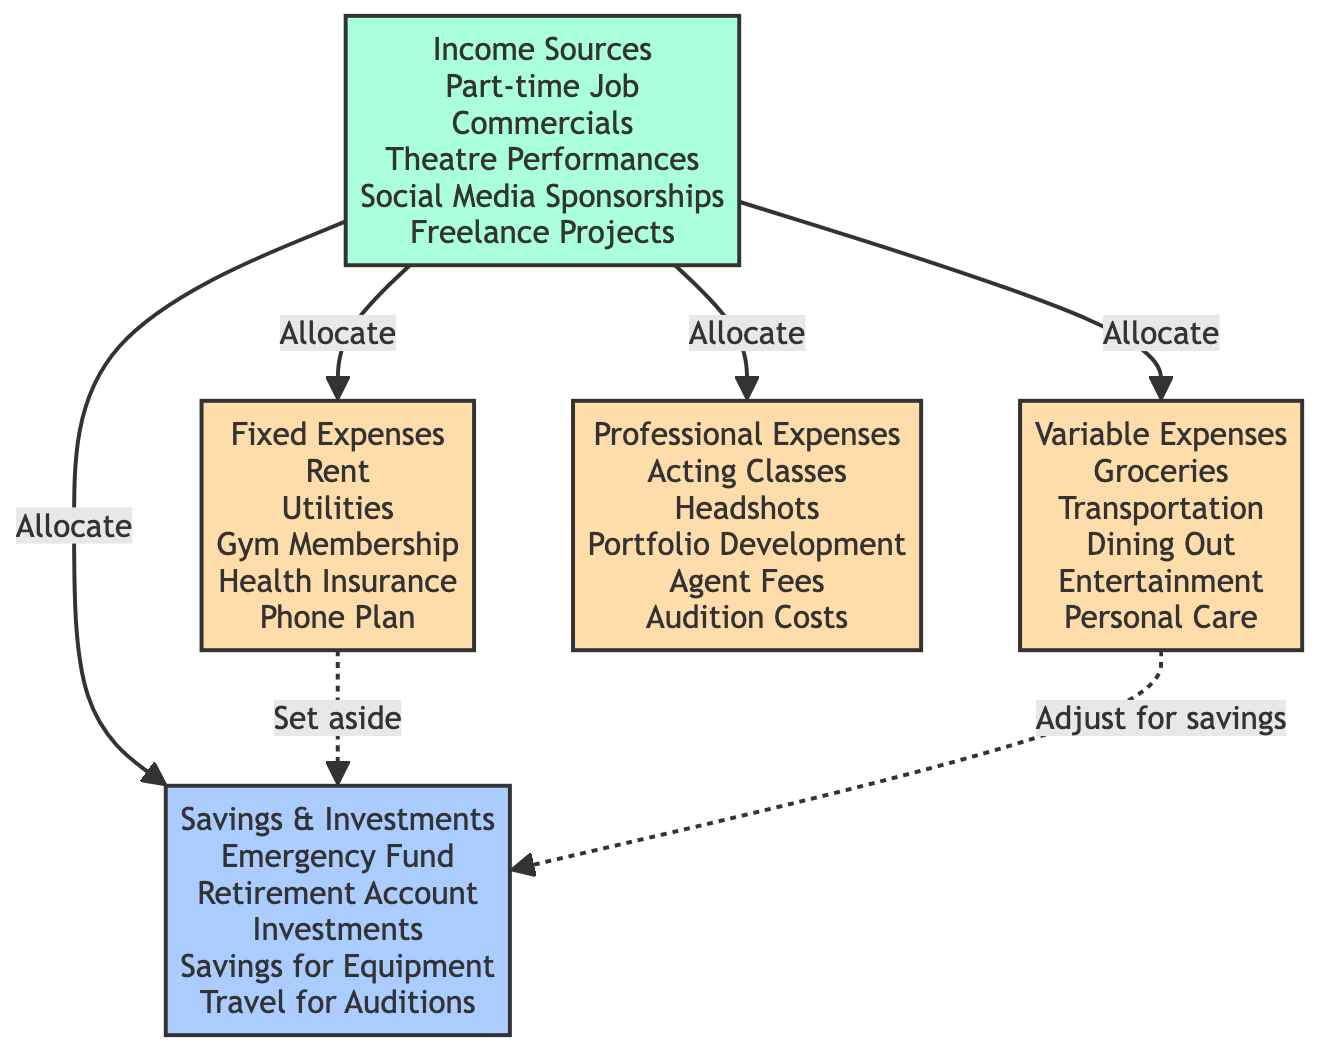What are the income sources listed in the diagram? The diagram details various income sources, including a part-time job, commercials, theatre performances, social media sponsorships, and freelance projects.
Answer: Part-time Job, Commercials, Theatre Performances, Social Media Sponsorships, Freelance Projects How many fixed expenses are mentioned? By counting the items listed under fixed expenses, which include rent, utilities, gym membership, health insurance, and phone plan, we find that there are five fixed expenses.
Answer: 5 What is the purpose of the arrows pointing from Income to other categories? The arrows indicate the allocation of income to various expense categories, specifically fixed expenses, variable expenses, professional expenses, and savings.
Answer: Allocate Which category suggests adjusting for savings? In the diagram, variable expenses include the note to adjust for savings, implying a need for flexibility to save money.
Answer: Variable Expenses How many types of expenses are categorized in the diagram? The diagram categorizes expenses into three distinct types: fixed expenses, variable expenses, and professional expenses, leading to a total of three expense types.
Answer: 3 What is the relationship between Fixed Expenses and Savings? The diagram illustrates that fixed expenses have a dotted arrow pointing to savings, indicating that a portion is set aside for savings from fixed expenses.
Answer: Set aside Name one type of professional expense listed. Among the professional expenses, items such as acting classes, headshots, portfolio development, agent fees, and audition costs are noted; one can refer to any of these as a valid example.
Answer: Acting Classes What does the diagram suggest about variable expenses towards savings? The relationship between variable expenses and savings is highlighted by the statement "adjust for savings," suggesting that variable expenses can be modified to prioritize saving money.
Answer: Adjust for savings Which category does the acting classes belong to? Acting classes are specifically noted under the professional expenses category, highlighting their significance in an aspiring actress's budget.
Answer: Professional Expenses 